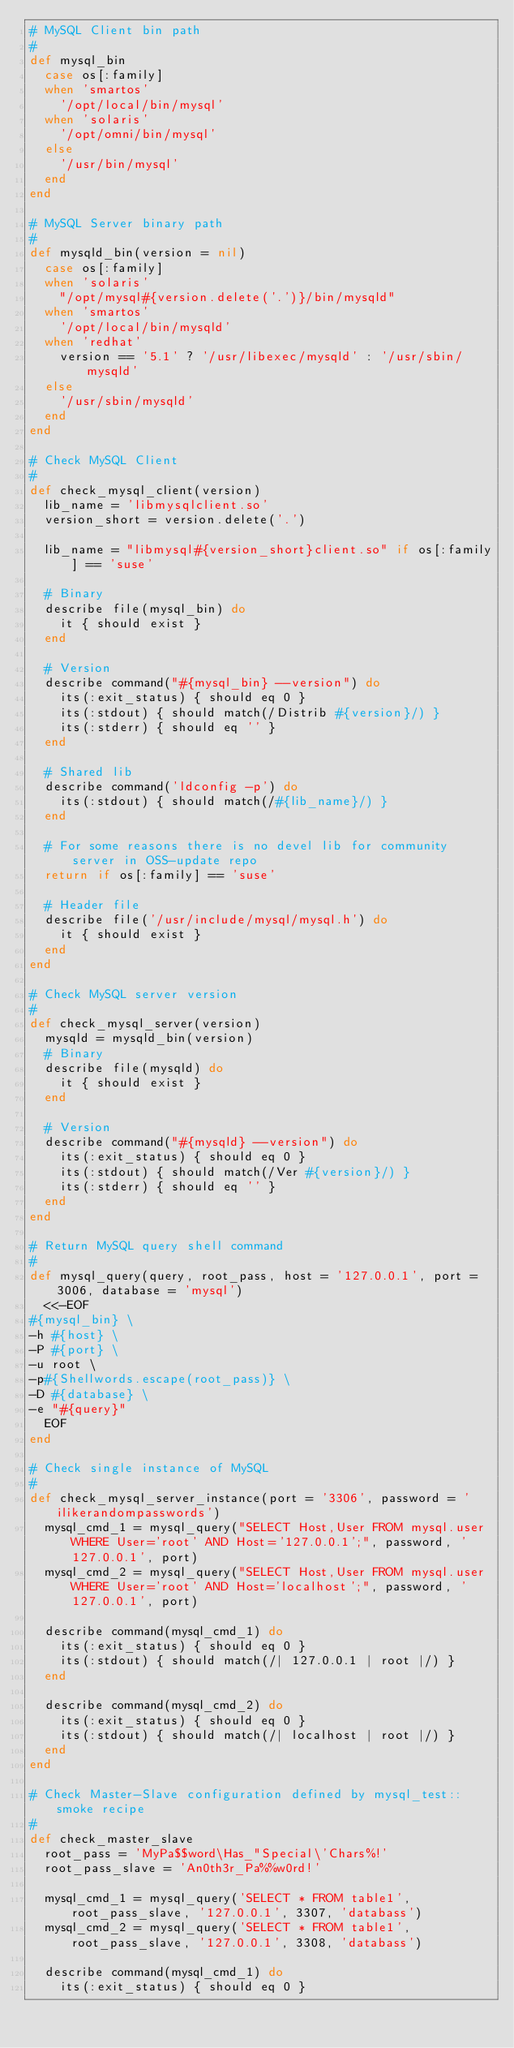<code> <loc_0><loc_0><loc_500><loc_500><_Ruby_># MySQL Client bin path
#
def mysql_bin
  case os[:family]
  when 'smartos'
    '/opt/local/bin/mysql'
  when 'solaris'
    '/opt/omni/bin/mysql'
  else
    '/usr/bin/mysql'
  end
end

# MySQL Server binary path
#
def mysqld_bin(version = nil)
  case os[:family]
  when 'solaris'
    "/opt/mysql#{version.delete('.')}/bin/mysqld"
  when 'smartos'
    '/opt/local/bin/mysqld'
  when 'redhat'
    version == '5.1' ? '/usr/libexec/mysqld' : '/usr/sbin/mysqld'
  else
    '/usr/sbin/mysqld'
  end
end

# Check MySQL Client
#
def check_mysql_client(version)
  lib_name = 'libmysqlclient.so'
  version_short = version.delete('.')

  lib_name = "libmysql#{version_short}client.so" if os[:family] == 'suse'

  # Binary
  describe file(mysql_bin) do
    it { should exist }
  end

  # Version
  describe command("#{mysql_bin} --version") do
    its(:exit_status) { should eq 0 }
    its(:stdout) { should match(/Distrib #{version}/) }
    its(:stderr) { should eq '' }
  end

  # Shared lib
  describe command('ldconfig -p') do
    its(:stdout) { should match(/#{lib_name}/) }
  end

  # For some reasons there is no devel lib for community server in OSS-update repo
  return if os[:family] == 'suse'

  # Header file
  describe file('/usr/include/mysql/mysql.h') do
    it { should exist }
  end
end

# Check MySQL server version
#
def check_mysql_server(version)
  mysqld = mysqld_bin(version)
  # Binary
  describe file(mysqld) do
    it { should exist }
  end

  # Version
  describe command("#{mysqld} --version") do
    its(:exit_status) { should eq 0 }
    its(:stdout) { should match(/Ver #{version}/) }
    its(:stderr) { should eq '' }
  end
end

# Return MySQL query shell command
#
def mysql_query(query, root_pass, host = '127.0.0.1', port = 3006, database = 'mysql')
  <<-EOF
#{mysql_bin} \
-h #{host} \
-P #{port} \
-u root \
-p#{Shellwords.escape(root_pass)} \
-D #{database} \
-e "#{query}"
  EOF
end

# Check single instance of MySQL
#
def check_mysql_server_instance(port = '3306', password = 'ilikerandompasswords')
  mysql_cmd_1 = mysql_query("SELECT Host,User FROM mysql.user WHERE User='root' AND Host='127.0.0.1';", password, '127.0.0.1', port)
  mysql_cmd_2 = mysql_query("SELECT Host,User FROM mysql.user WHERE User='root' AND Host='localhost';", password, '127.0.0.1', port)

  describe command(mysql_cmd_1) do
    its(:exit_status) { should eq 0 }
    its(:stdout) { should match(/| 127.0.0.1 | root |/) }
  end

  describe command(mysql_cmd_2) do
    its(:exit_status) { should eq 0 }
    its(:stdout) { should match(/| localhost | root |/) }
  end
end

# Check Master-Slave configuration defined by mysql_test::smoke recipe
#
def check_master_slave
  root_pass = 'MyPa$$word\Has_"Special\'Chars%!'
  root_pass_slave = 'An0th3r_Pa%%w0rd!'

  mysql_cmd_1 = mysql_query('SELECT * FROM table1', root_pass_slave, '127.0.0.1', 3307, 'databass')
  mysql_cmd_2 = mysql_query('SELECT * FROM table1', root_pass_slave, '127.0.0.1', 3308, 'databass')

  describe command(mysql_cmd_1) do
    its(:exit_status) { should eq 0 }</code> 